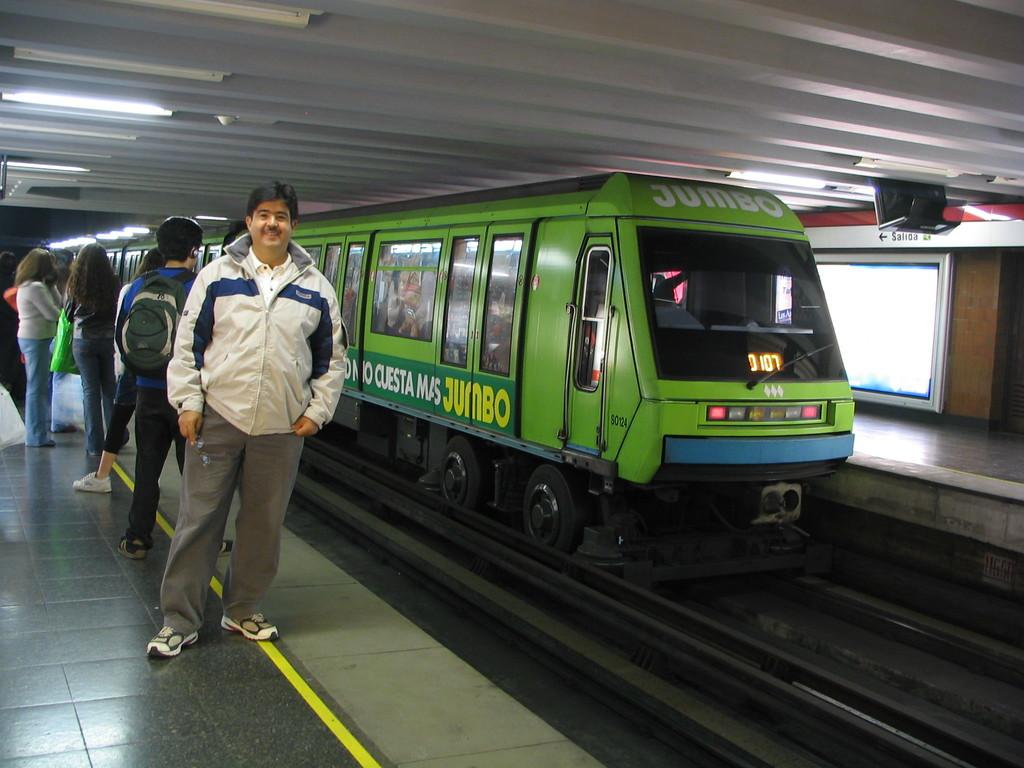What is the main subject of the image? The main subject of the image is a train on a railway track. Where is the train located in the image? The train is in the middle of the image. What else can be seen on the left side of the image? There are people standing on the left side of the image. What is visible at the top of the image? The roof is visible at the top of the image. What type of prose can be heard being read by the people on the left side of the image? There is no indication in the image that people are reading or that any prose is being read. --- 